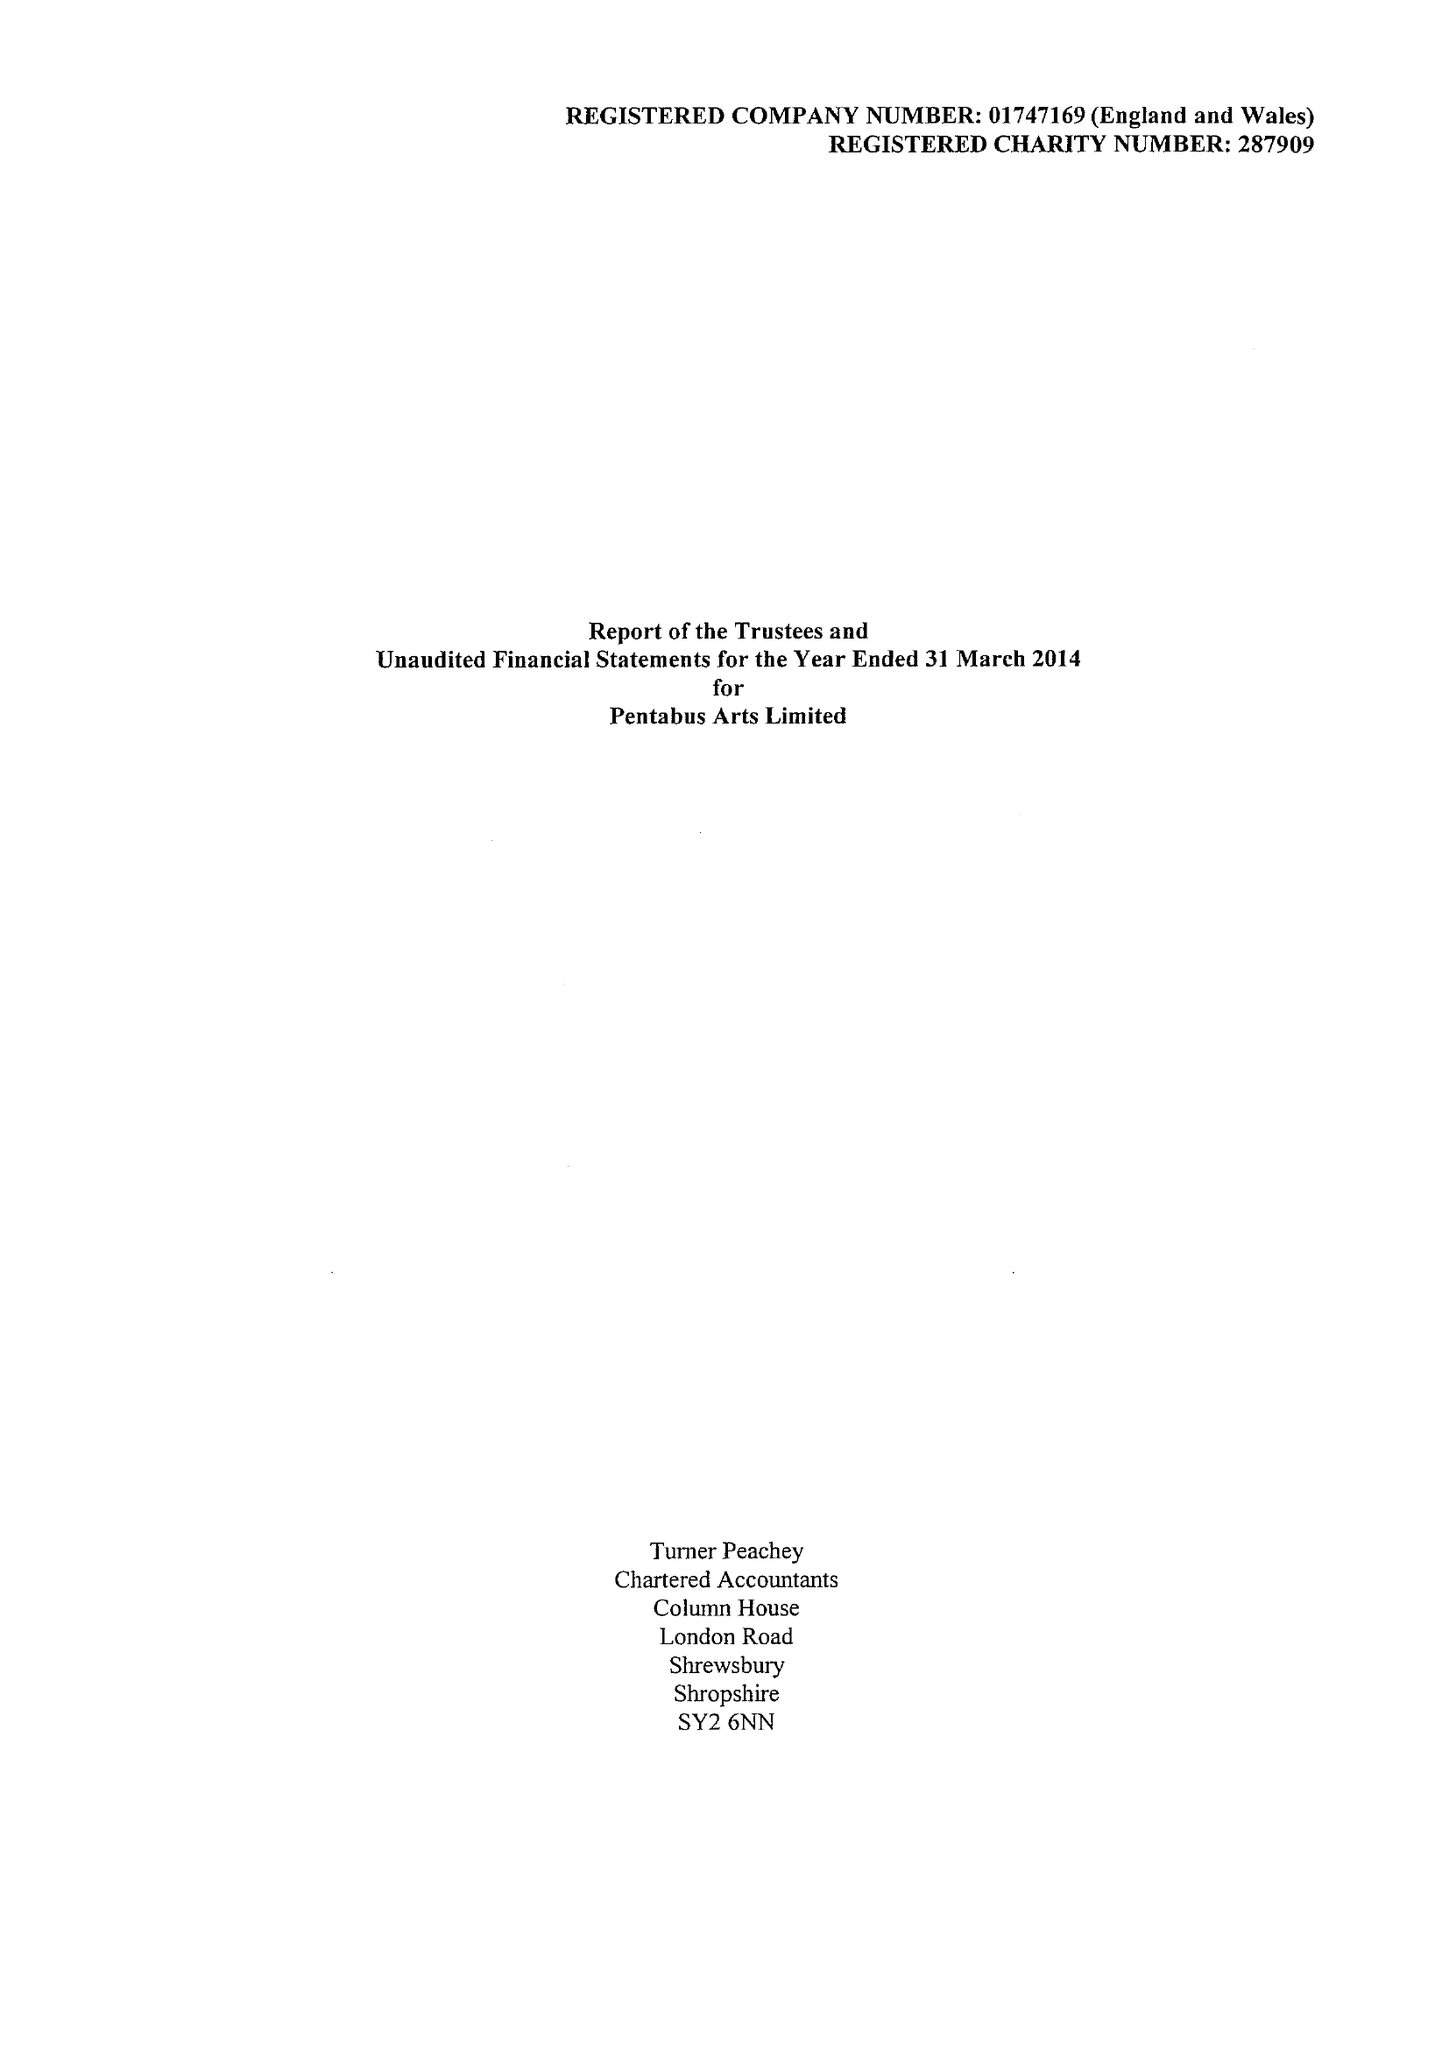What is the value for the address__street_line?
Answer the question using a single word or phrase. THE OLD SCHOOL 